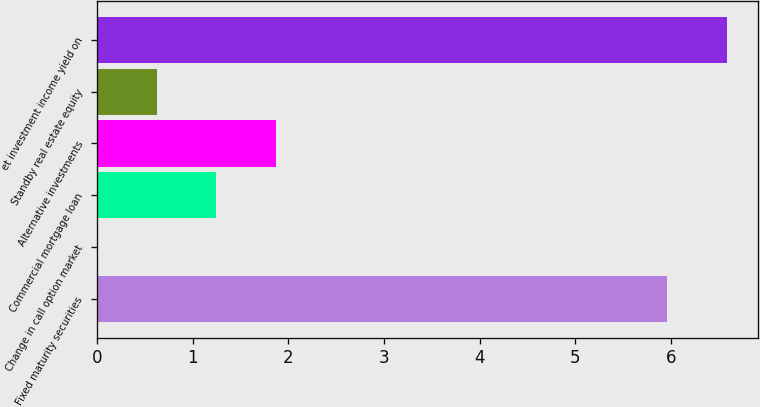Convert chart. <chart><loc_0><loc_0><loc_500><loc_500><bar_chart><fcel>Fixed maturity securities<fcel>Change in call option market<fcel>Commercial mortgage loan<fcel>Alternative investments<fcel>Standby real estate equity<fcel>et investment income yield on<nl><fcel>5.96<fcel>0.01<fcel>1.25<fcel>1.87<fcel>0.63<fcel>6.58<nl></chart> 